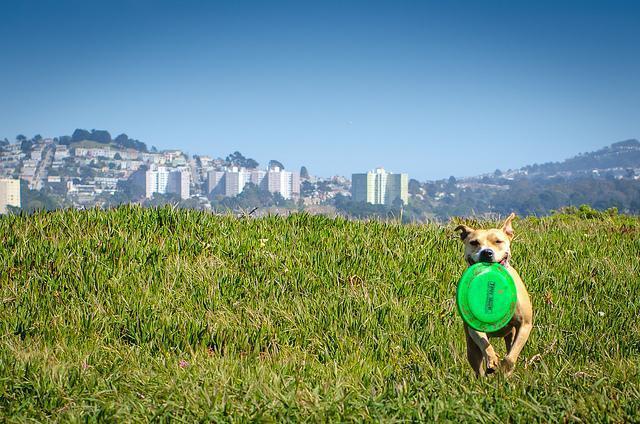How many dogs are in the picture?
Give a very brief answer. 1. 